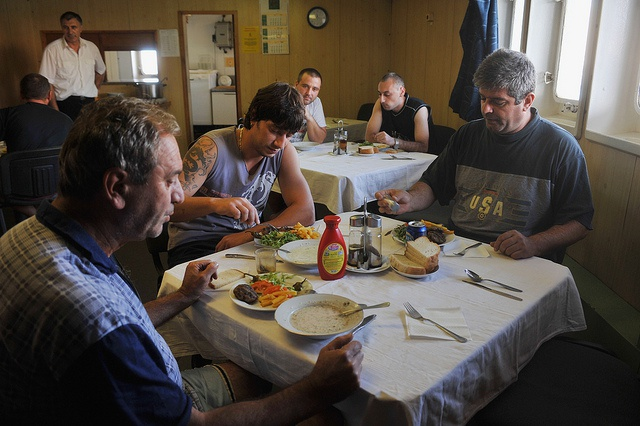Describe the objects in this image and their specific colors. I can see people in black, maroon, and gray tones, dining table in black, darkgray, gray, and tan tones, people in black, gray, and maroon tones, people in black, maroon, and gray tones, and dining table in black, darkgray, gray, and lightgray tones in this image. 